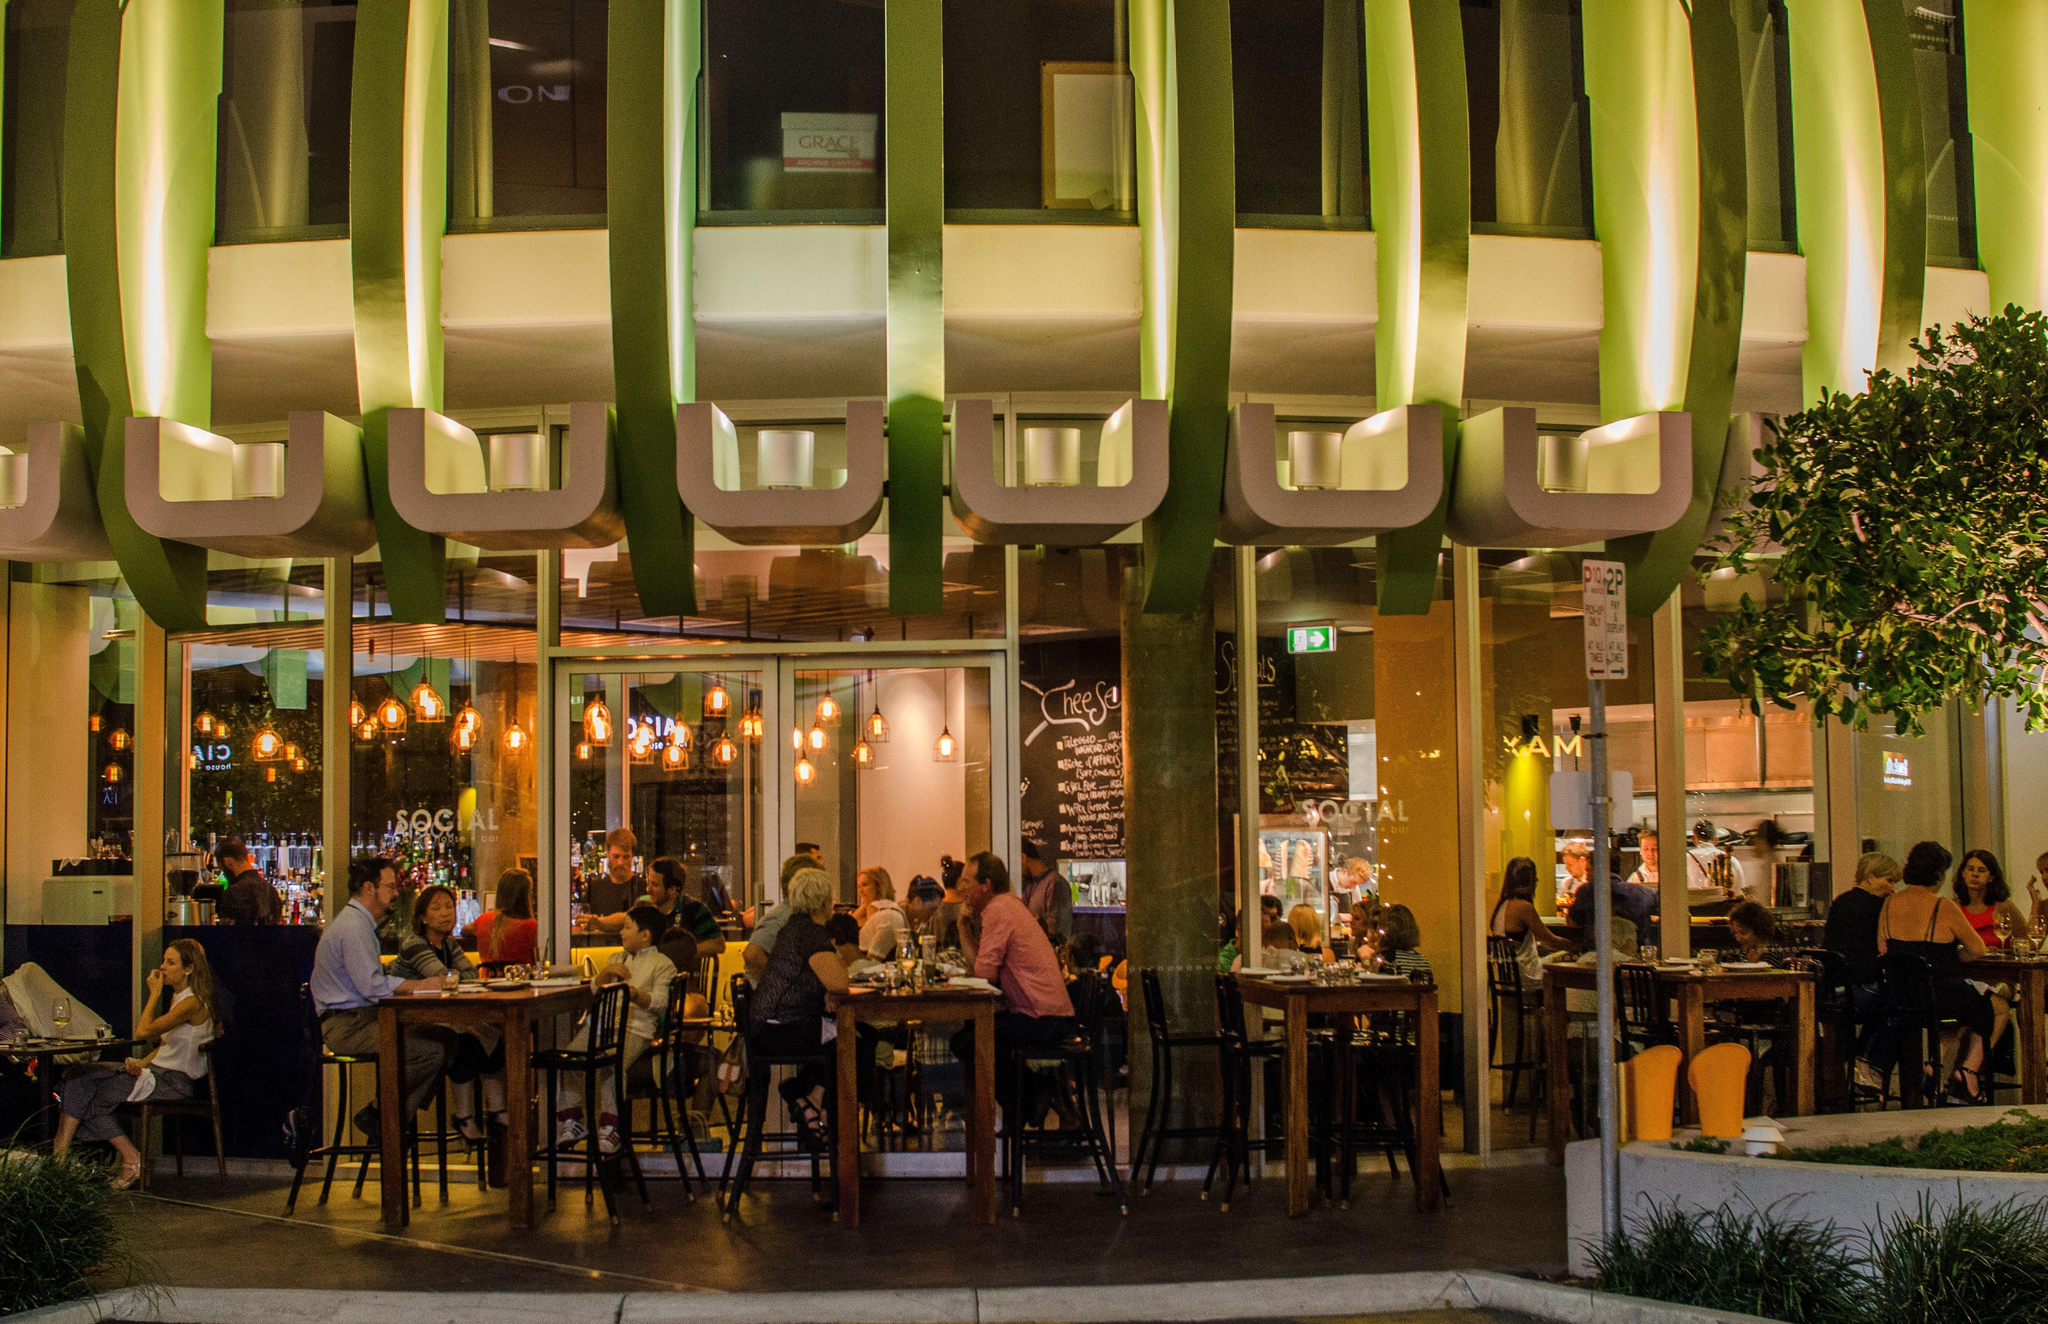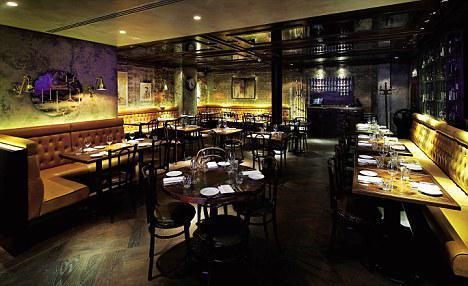The first image is the image on the left, the second image is the image on the right. Analyze the images presented: Is the assertion "The left image shows patrons dining at an establishment that features a curve of greenish columns, with a tree visible on the exterior." valid? Answer yes or no. Yes. 